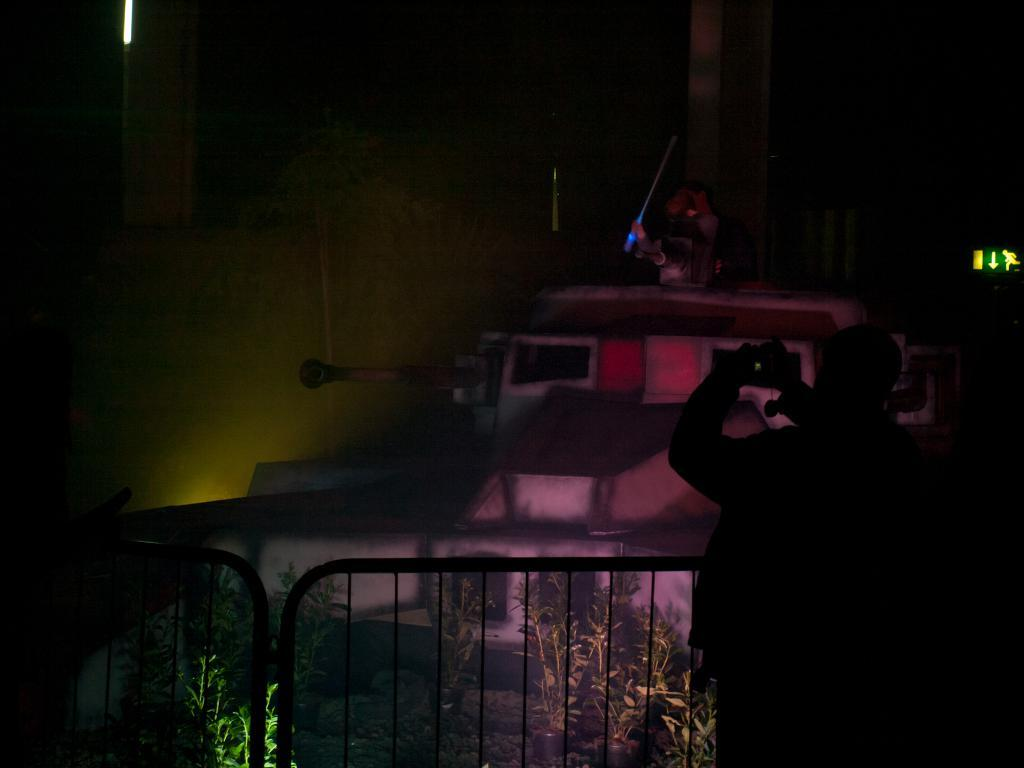Who or what is present in the image? There is a person in the image. What is the person standing near or interacting with? There is a fence in the image. What type of vegetation can be seen in the image? There are plants in the image. What large object is visible in the image? There is a tanker in the image. What is the board used for in the image? The purpose of the board in the image is not clear, but it is present. What type of truck can be seen driving through the fence in the image? There is no truck present in the image, nor is there any indication of a truck driving through the fence. 